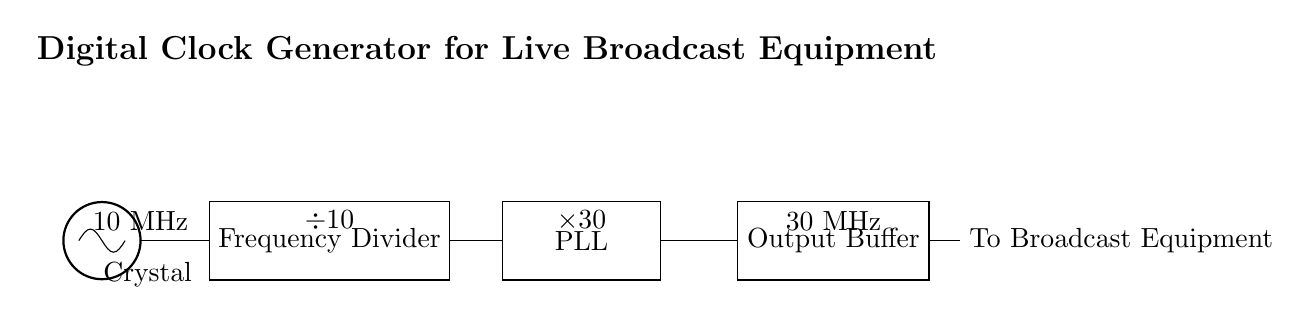What is the frequency of the oscillator? The frequency of the oscillator is indicated as 10 MHz, which is labeled above the crystal component in the circuit diagram.
Answer: 10 MHz What is the overall output frequency after the output buffer? The output frequency is displayed as 30 MHz, which can be found above the output buffer component in the diagram.
Answer: 30 MHz What does the frequency divider do? The frequency divider reduces the input frequency by a factor of 10, which is explicitly denoted by the ÷10 label above the frequency divider in the circuit.
Answer: ÷10 What amplification does the phase-locked loop (PLL) provide? The PLL amplifies the signal by a factor of 30, as indicated by the ×30 label above the PLL component in the diagram.
Answer: ×30 What type of component is the first element in the circuit? The first component in the circuit is a crystal oscillator, which is specifically designed to provide a stable clock signal.
Answer: Crystal How many stages are in the circuit? The circuit consists of four main stages: the oscillator, frequency divider, phase-locked loop, and output buffer. This is determined by counting the distinct components in the diagram.
Answer: Four Which component connects the oscillator to the frequency divider? The connection from the oscillator to the frequency divider is a direct line, which indicates a straightforward pathway for the clock signal.
Answer: Oscillator 